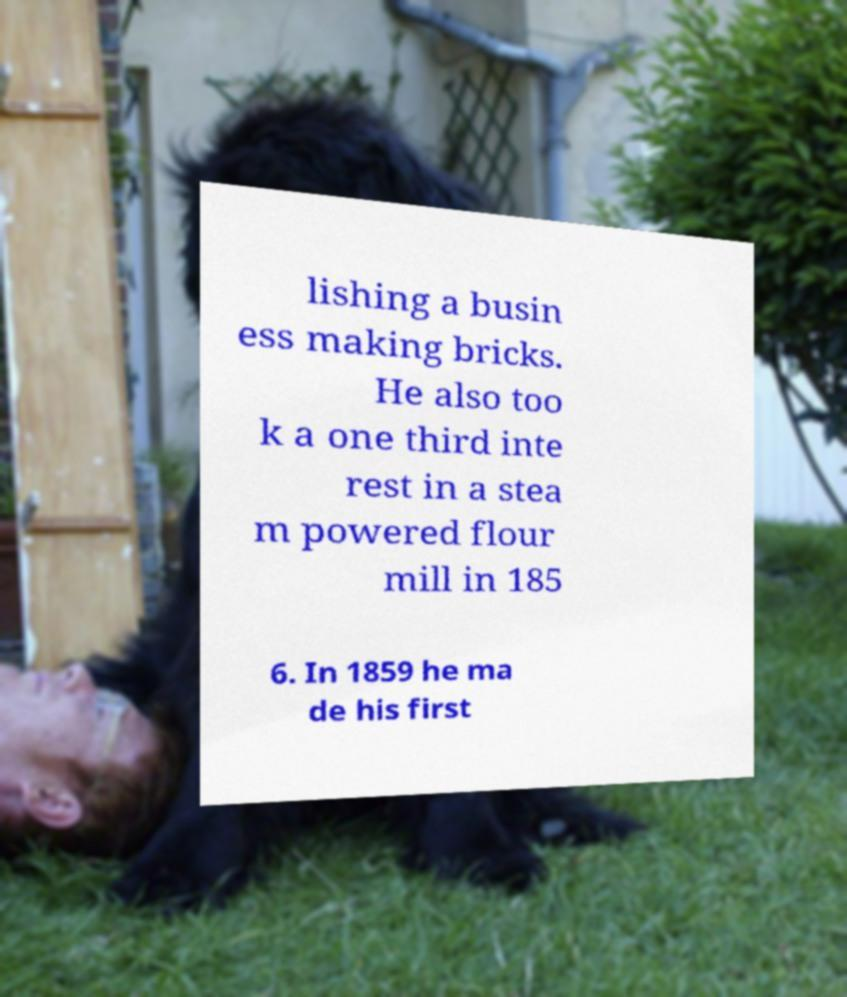Can you read and provide the text displayed in the image?This photo seems to have some interesting text. Can you extract and type it out for me? lishing a busin ess making bricks. He also too k a one third inte rest in a stea m powered flour mill in 185 6. In 1859 he ma de his first 